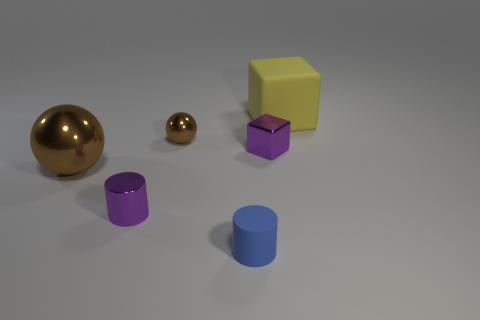Add 3 shiny balls. How many objects exist? 9 Subtract all cubes. How many objects are left? 4 Subtract 0 green cubes. How many objects are left? 6 Subtract all cyan metal cylinders. Subtract all purple shiny objects. How many objects are left? 4 Add 4 big yellow matte things. How many big yellow matte things are left? 5 Add 2 gray matte cylinders. How many gray matte cylinders exist? 2 